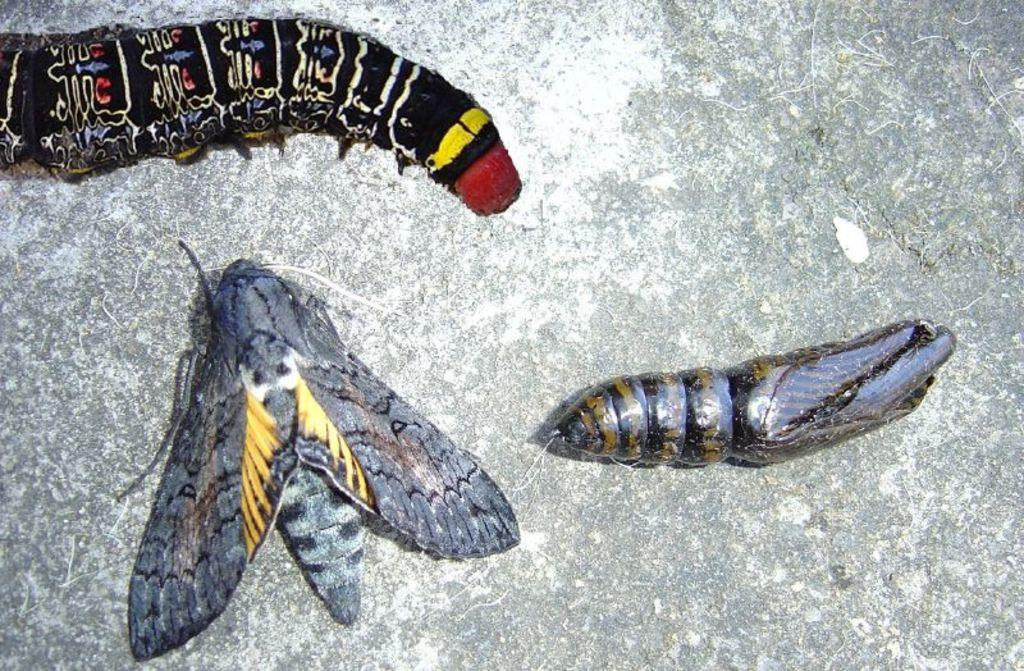What types of creatures are present in the image? There are different types of insects in the image. What can be seen at the bottom of the image? There appears to be a rock at the bottom of the image. What type of stick is being used by the insects to grow in the image? There is no stick present in the image, and the insects are not shown growing. 